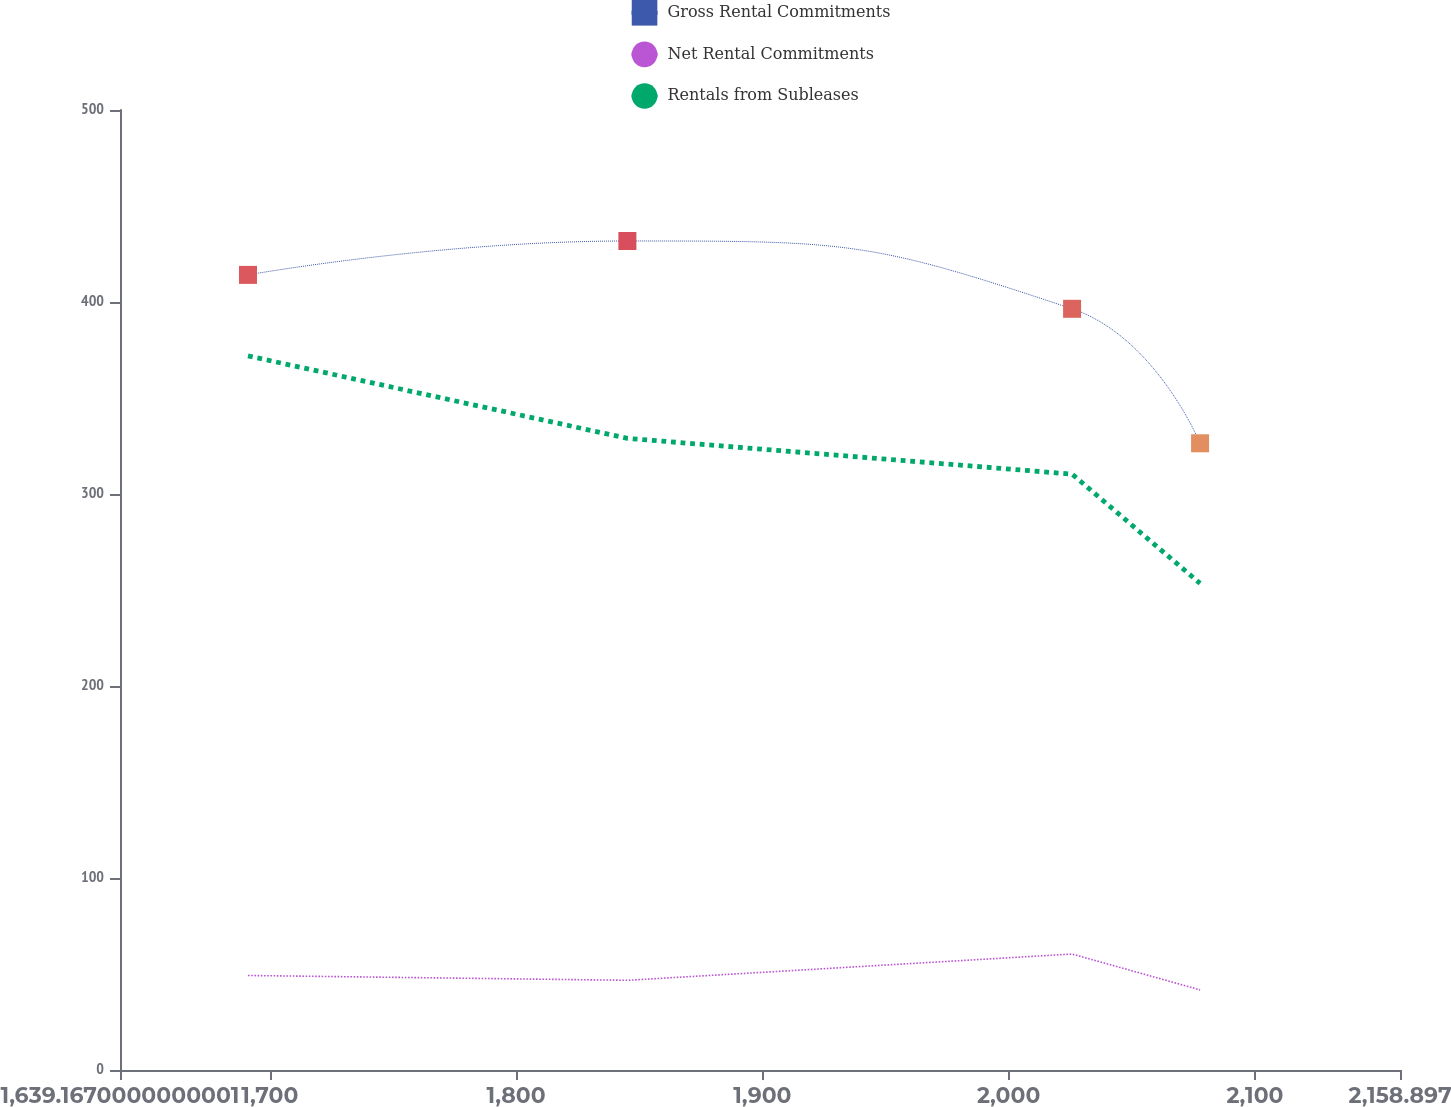Convert chart to OTSL. <chart><loc_0><loc_0><loc_500><loc_500><line_chart><ecel><fcel>Gross Rental Commitments<fcel>Net Rental Commitments<fcel>Rentals from Subleases<nl><fcel>1691.14<fcel>414.12<fcel>49.23<fcel>371.94<nl><fcel>1845.19<fcel>431.78<fcel>46.72<fcel>328.98<nl><fcel>2025.75<fcel>396.46<fcel>60.4<fcel>310.35<nl><fcel>2077.72<fcel>326.41<fcel>41.73<fcel>253.45<nl><fcel>2210.87<fcel>254.14<fcel>35.32<fcel>185.63<nl></chart> 